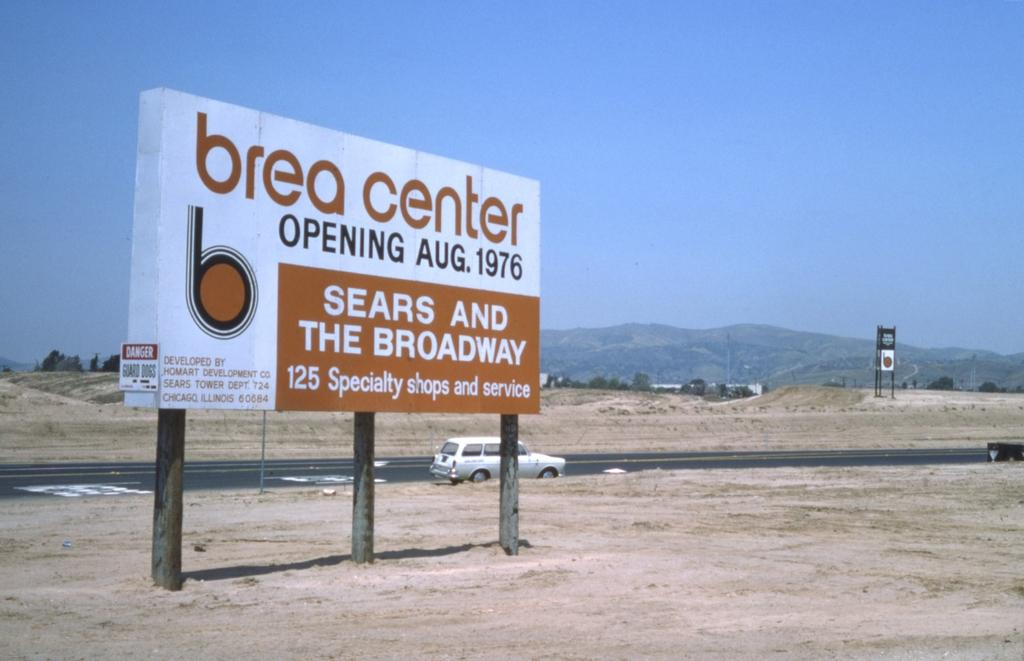Provide a one-sentence caption for the provided image. An advertisement for the Brea Center in the middle of the desert on a clear day. 